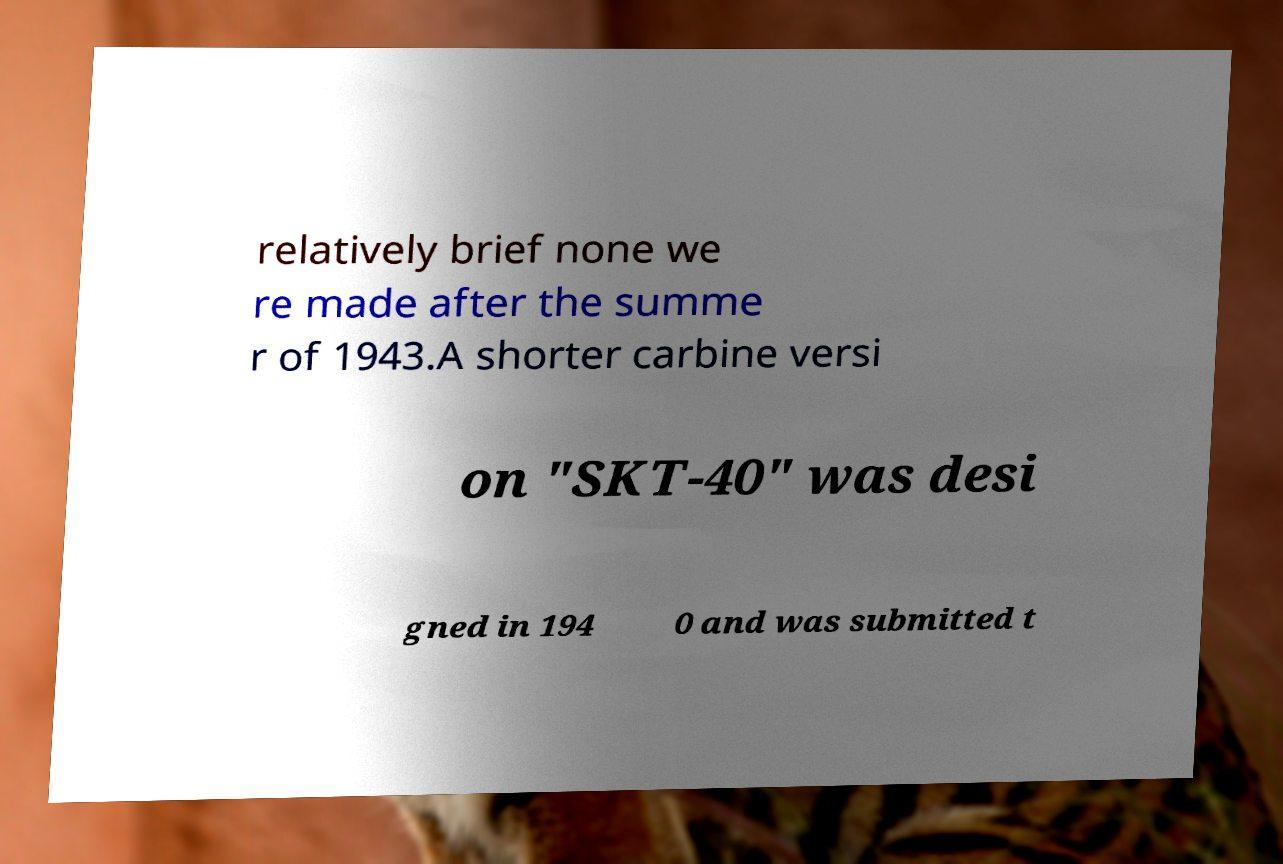For documentation purposes, I need the text within this image transcribed. Could you provide that? relatively brief none we re made after the summe r of 1943.A shorter carbine versi on "SKT-40" was desi gned in 194 0 and was submitted t 